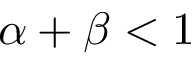<formula> <loc_0><loc_0><loc_500><loc_500>\alpha + \beta < 1</formula> 